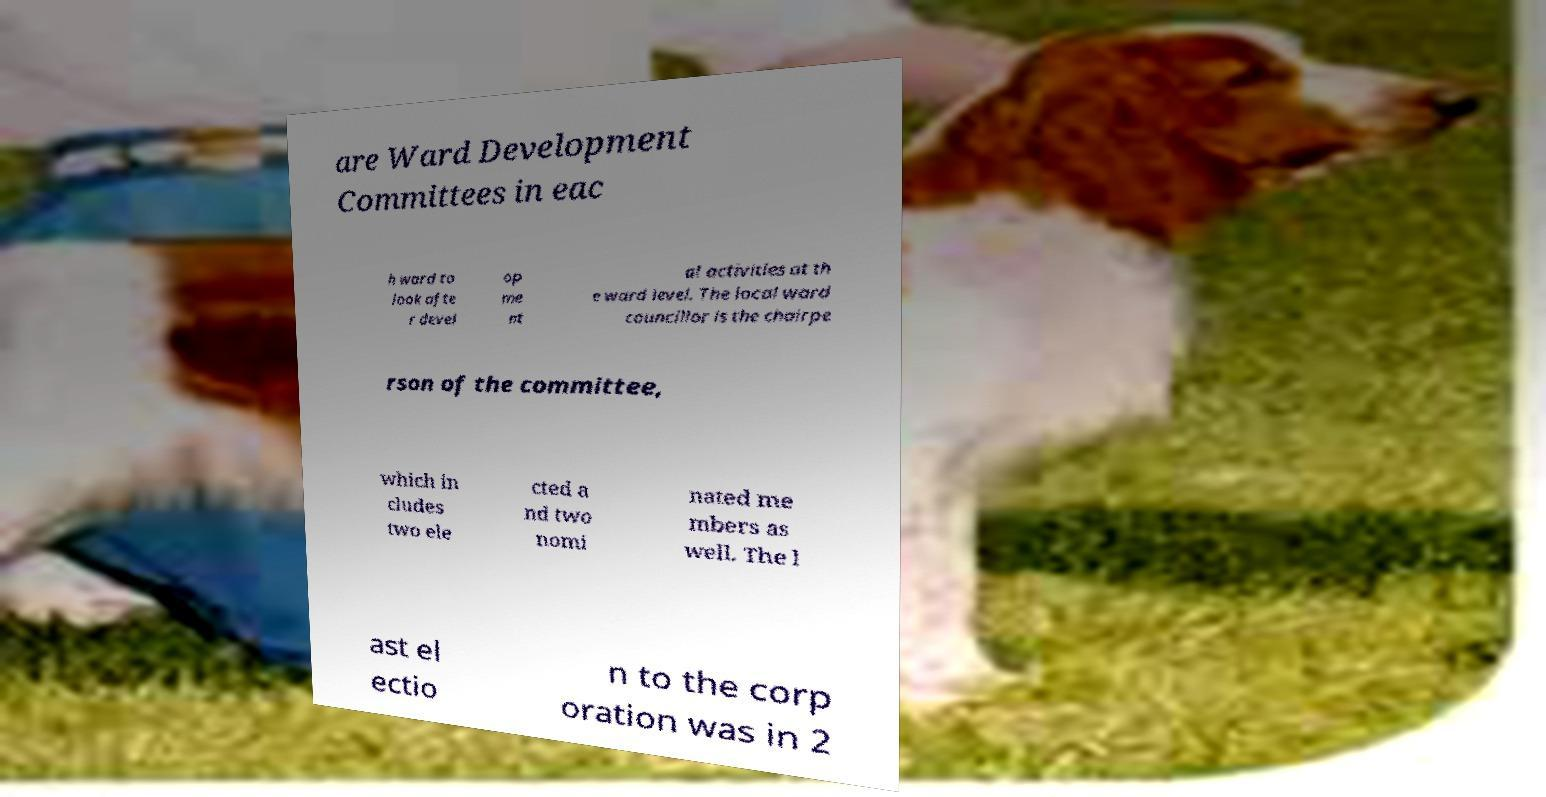For documentation purposes, I need the text within this image transcribed. Could you provide that? are Ward Development Committees in eac h ward to look afte r devel op me nt al activities at th e ward level. The local ward councillor is the chairpe rson of the committee, which in cludes two ele cted a nd two nomi nated me mbers as well. The l ast el ectio n to the corp oration was in 2 